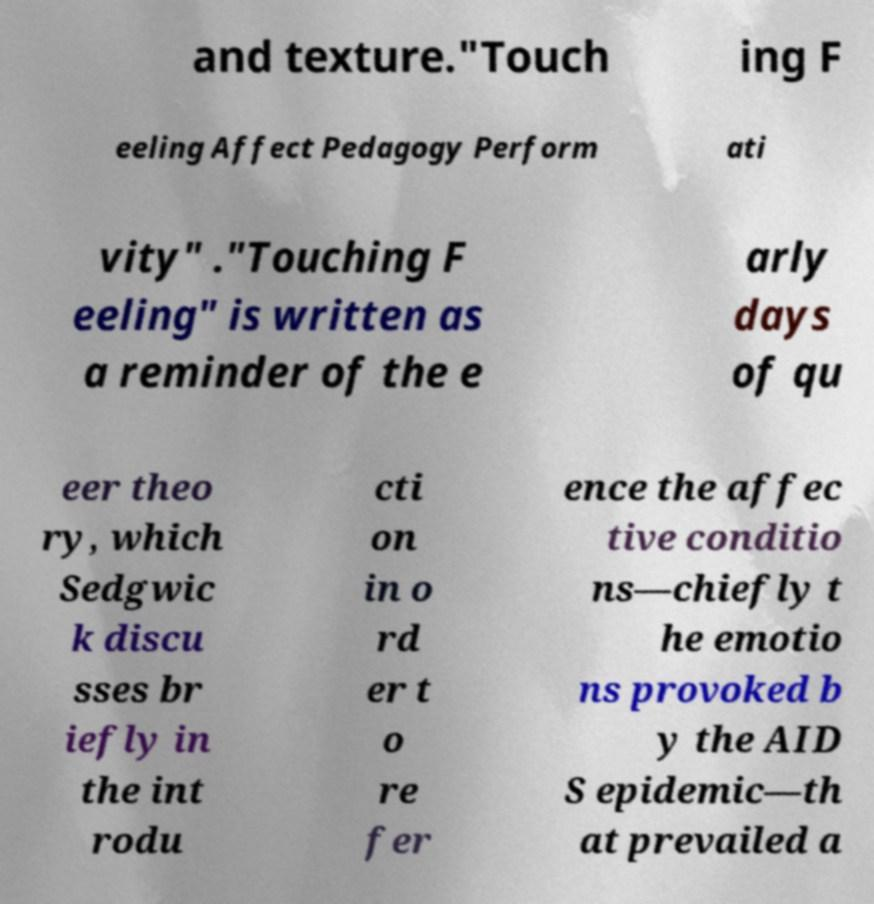Could you assist in decoding the text presented in this image and type it out clearly? and texture."Touch ing F eeling Affect Pedagogy Perform ati vity" ."Touching F eeling" is written as a reminder of the e arly days of qu eer theo ry, which Sedgwic k discu sses br iefly in the int rodu cti on in o rd er t o re fer ence the affec tive conditio ns—chiefly t he emotio ns provoked b y the AID S epidemic—th at prevailed a 